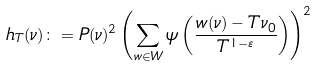Convert formula to latex. <formula><loc_0><loc_0><loc_500><loc_500>h _ { T } ( \nu ) \colon = P ( \nu ) ^ { 2 } \left ( \sum _ { w \in W } \psi \left ( \frac { w ( \nu ) - T \nu _ { 0 } } { T ^ { 1 - \varepsilon } } \right ) \right ) ^ { 2 }</formula> 